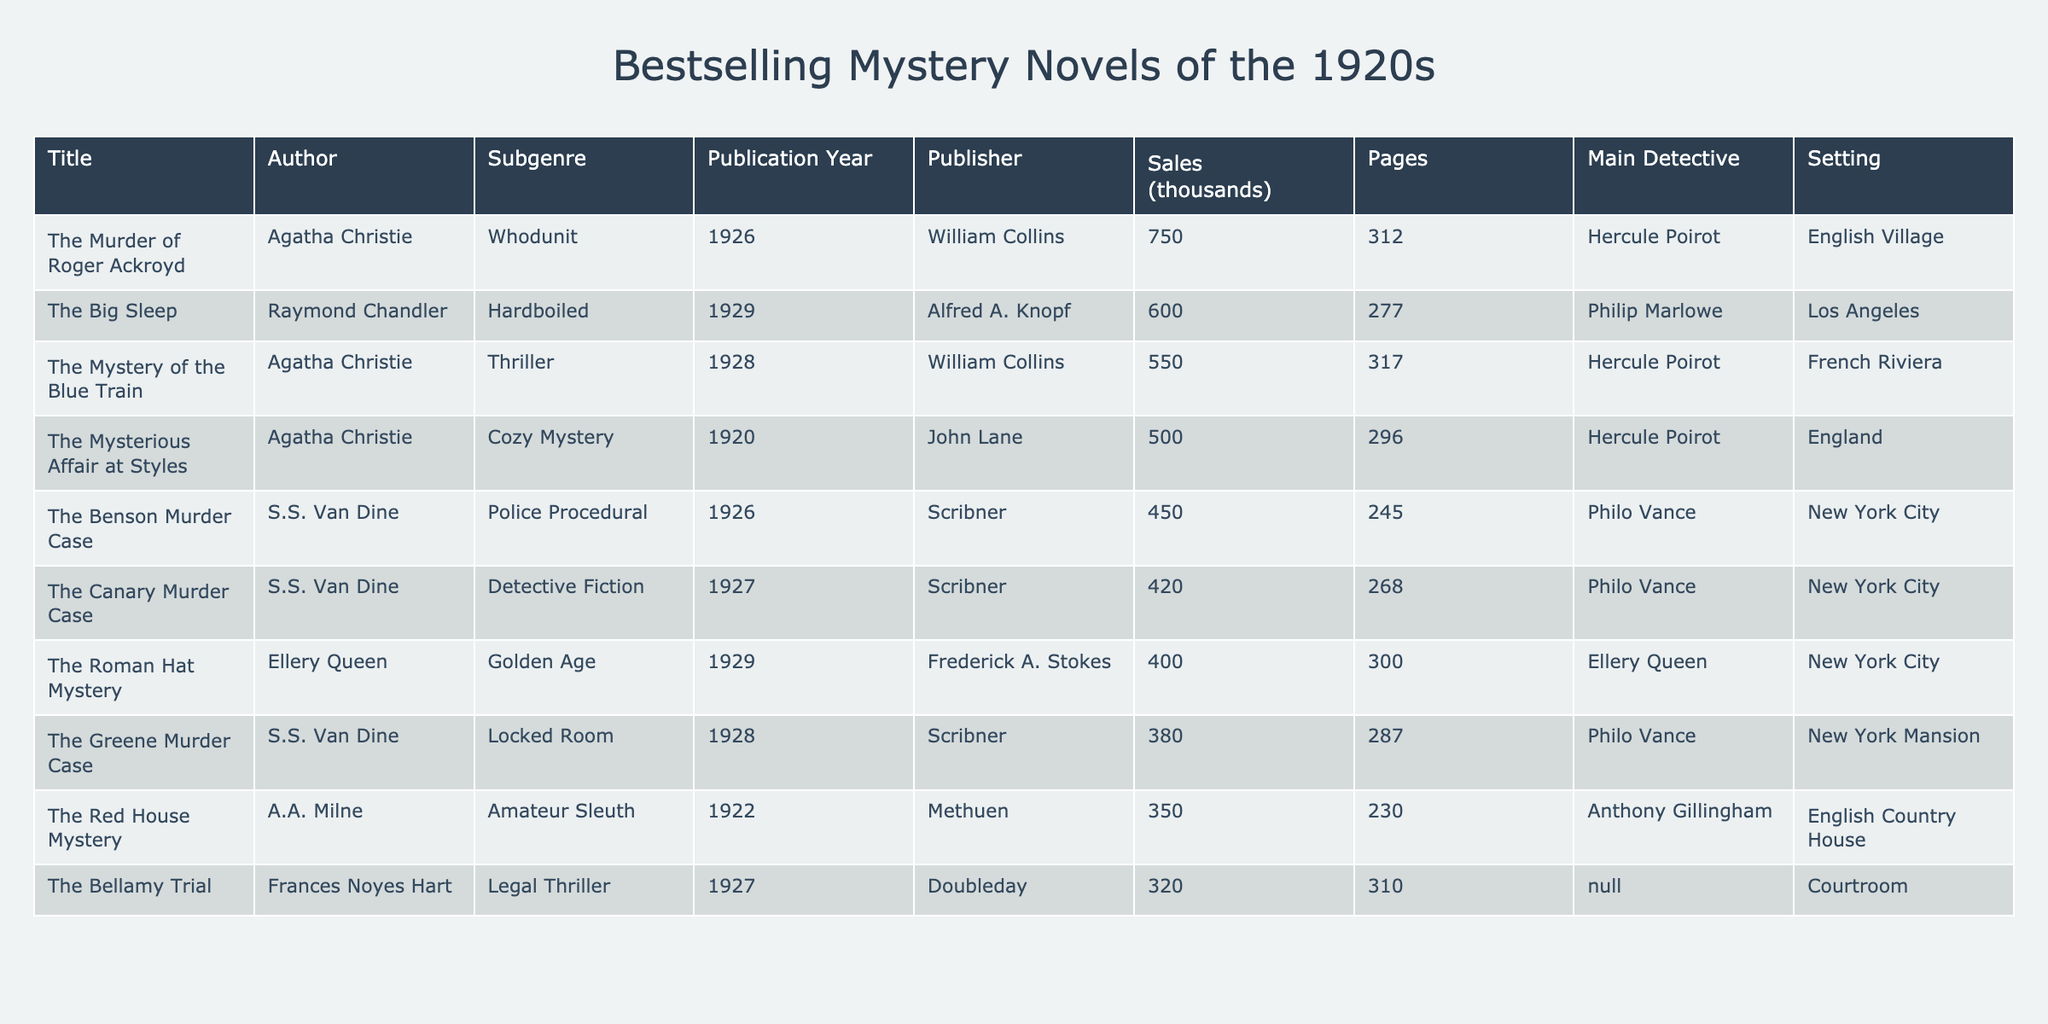What is the bestselling mystery novel of the 1920s? From the table, the title with the highest sales figure is "The Murder of Roger Ackroyd" with sales of 750 thousand.
Answer: The Murder of Roger Ackroyd Which author wrote the most books listed in this table? By examining the authors in the table, Agatha Christie has written three novels: "The Mysterious Affair at Styles," "The Murder of Roger Ackroyd," and "The Mystery of the Blue Train."
Answer: Agatha Christie What is the total sales figure for all novels in the table? To find the total sales, we sum up all the sales figures: 500 + 350 + 450 + 750 + 600 + 400 + 380 + 320 + 550 + 420 = 3920 thousand.
Answer: 3920 thousand Which subgenre has the most books listed in the table? Counting each subgenre, "Detective Fiction" (1), "Cozy Mystery" (1), "Amateur Sleuth" (1), "Police Procedural" (1), "Whodunit" (1), "Hardboiled" (1), "Golden Age" (1), "Locked Room" (1), "Legal Thriller" (1), and "Thriller" (1) show that all subgenres are represented once. Thus, there is a tie among all.
Answer: There is a tie What is the average number of pages for the novels in this table? To find the average, we first sum the page counts: 296 + 230 + 245 + 312 + 277 + 300 + 287 + 310 + 317 + 268 = 2,542. Then, we divide by the number of novels, which is 10: 2,542 / 10 = 254.2.
Answer: 254.2 pages Does the book "The Big Sleep" have the same main detective as any other book in the table? The main detective of "The Big Sleep" is Philip Marlowe, and reviewing the table shows that no other novel features this detective, as others have different main characters.
Answer: No What is the difference in sales between the bestselling novel and the second bestselling novel? The bestselling novel is "The Murder of Roger Ackroyd" (750 thousand) and the second bestselling is "The Big Sleep" (600 thousand). The difference is 750 - 600 = 150 thousand.
Answer: 150 thousand Which book has the highest page count and what is that count? By reviewing the page counts in the table, "The Bellamy Trial" has the highest number with 310 pages.
Answer: 310 pages Are there any novels set in New York City? There are four novels set in New York City: "The Benson Murder Case," "The Roman Hat Mystery," "The Canary Murder Case," and "The Big Sleep."
Answer: Yes What is the most recent publication year for a book in this table? The most recent year listed in the table is 1929, which corresponds to "The Big Sleep" and "The Roman Hat Mystery."
Answer: 1929 